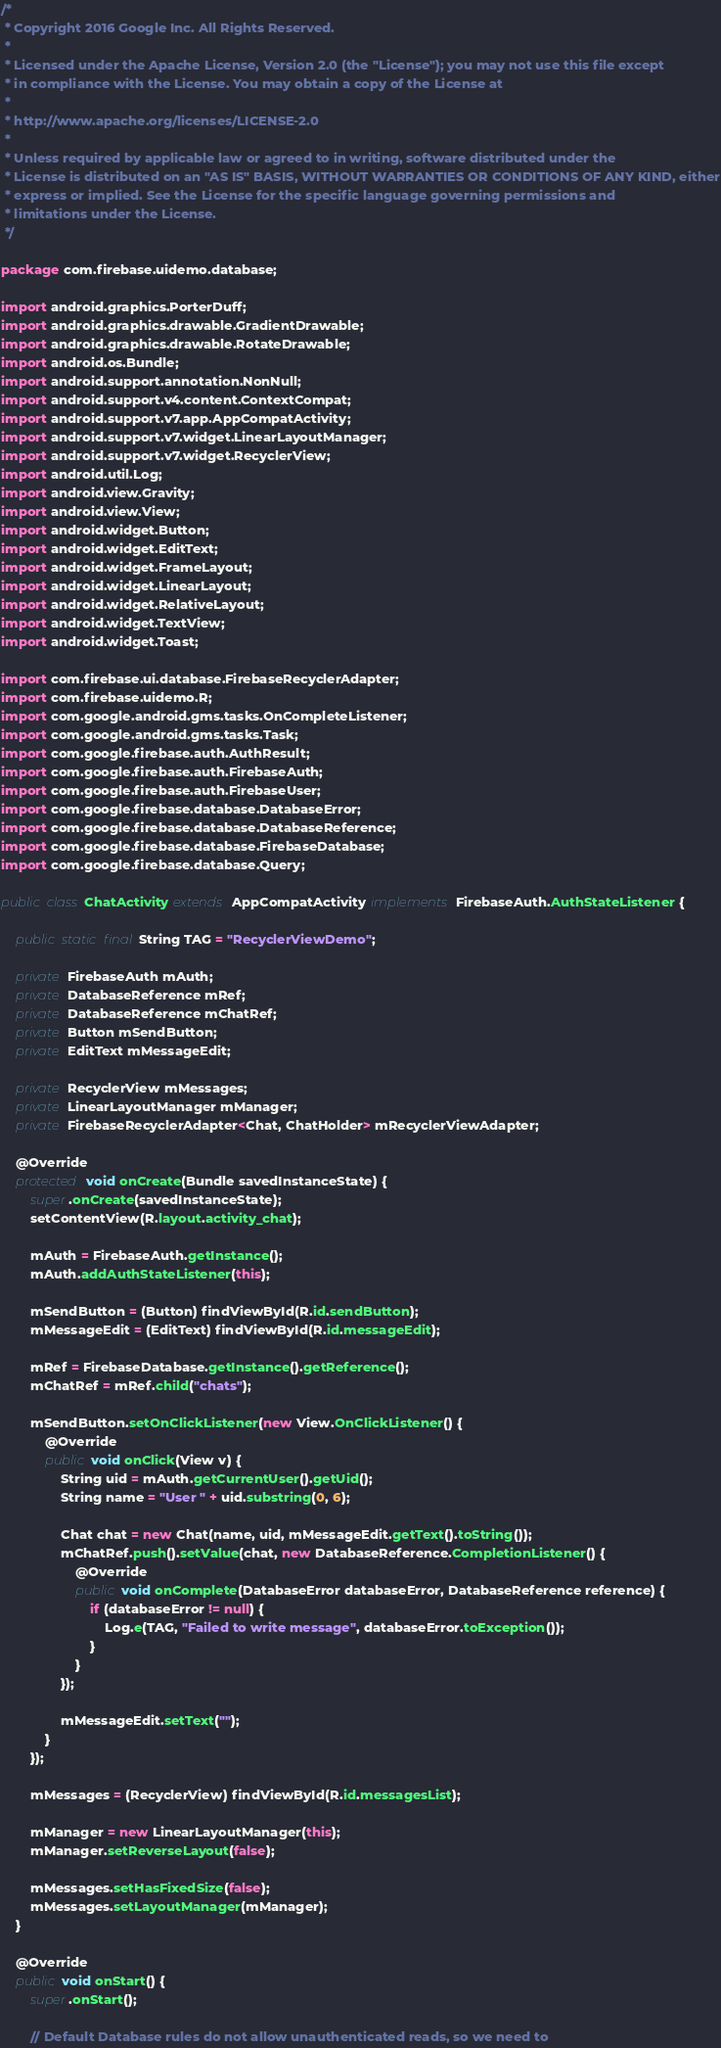<code> <loc_0><loc_0><loc_500><loc_500><_Java_>/*
 * Copyright 2016 Google Inc. All Rights Reserved.
 *
 * Licensed under the Apache License, Version 2.0 (the "License"); you may not use this file except
 * in compliance with the License. You may obtain a copy of the License at
 *
 * http://www.apache.org/licenses/LICENSE-2.0
 *
 * Unless required by applicable law or agreed to in writing, software distributed under the
 * License is distributed on an "AS IS" BASIS, WITHOUT WARRANTIES OR CONDITIONS OF ANY KIND, either
 * express or implied. See the License for the specific language governing permissions and
 * limitations under the License.
 */

package com.firebase.uidemo.database;

import android.graphics.PorterDuff;
import android.graphics.drawable.GradientDrawable;
import android.graphics.drawable.RotateDrawable;
import android.os.Bundle;
import android.support.annotation.NonNull;
import android.support.v4.content.ContextCompat;
import android.support.v7.app.AppCompatActivity;
import android.support.v7.widget.LinearLayoutManager;
import android.support.v7.widget.RecyclerView;
import android.util.Log;
import android.view.Gravity;
import android.view.View;
import android.widget.Button;
import android.widget.EditText;
import android.widget.FrameLayout;
import android.widget.LinearLayout;
import android.widget.RelativeLayout;
import android.widget.TextView;
import android.widget.Toast;

import com.firebase.ui.database.FirebaseRecyclerAdapter;
import com.firebase.uidemo.R;
import com.google.android.gms.tasks.OnCompleteListener;
import com.google.android.gms.tasks.Task;
import com.google.firebase.auth.AuthResult;
import com.google.firebase.auth.FirebaseAuth;
import com.google.firebase.auth.FirebaseUser;
import com.google.firebase.database.DatabaseError;
import com.google.firebase.database.DatabaseReference;
import com.google.firebase.database.FirebaseDatabase;
import com.google.firebase.database.Query;

public class ChatActivity extends AppCompatActivity implements FirebaseAuth.AuthStateListener {

    public static final String TAG = "RecyclerViewDemo";

    private FirebaseAuth mAuth;
    private DatabaseReference mRef;
    private DatabaseReference mChatRef;
    private Button mSendButton;
    private EditText mMessageEdit;

    private RecyclerView mMessages;
    private LinearLayoutManager mManager;
    private FirebaseRecyclerAdapter<Chat, ChatHolder> mRecyclerViewAdapter;

    @Override
    protected void onCreate(Bundle savedInstanceState) {
        super.onCreate(savedInstanceState);
        setContentView(R.layout.activity_chat);

        mAuth = FirebaseAuth.getInstance();
        mAuth.addAuthStateListener(this);

        mSendButton = (Button) findViewById(R.id.sendButton);
        mMessageEdit = (EditText) findViewById(R.id.messageEdit);

        mRef = FirebaseDatabase.getInstance().getReference();
        mChatRef = mRef.child("chats");

        mSendButton.setOnClickListener(new View.OnClickListener() {
            @Override
            public void onClick(View v) {
                String uid = mAuth.getCurrentUser().getUid();
                String name = "User " + uid.substring(0, 6);

                Chat chat = new Chat(name, uid, mMessageEdit.getText().toString());
                mChatRef.push().setValue(chat, new DatabaseReference.CompletionListener() {
                    @Override
                    public void onComplete(DatabaseError databaseError, DatabaseReference reference) {
                        if (databaseError != null) {
                            Log.e(TAG, "Failed to write message", databaseError.toException());
                        }
                    }
                });

                mMessageEdit.setText("");
            }
        });

        mMessages = (RecyclerView) findViewById(R.id.messagesList);

        mManager = new LinearLayoutManager(this);
        mManager.setReverseLayout(false);

        mMessages.setHasFixedSize(false);
        mMessages.setLayoutManager(mManager);
    }

    @Override
    public void onStart() {
        super.onStart();

        // Default Database rules do not allow unauthenticated reads, so we need to</code> 